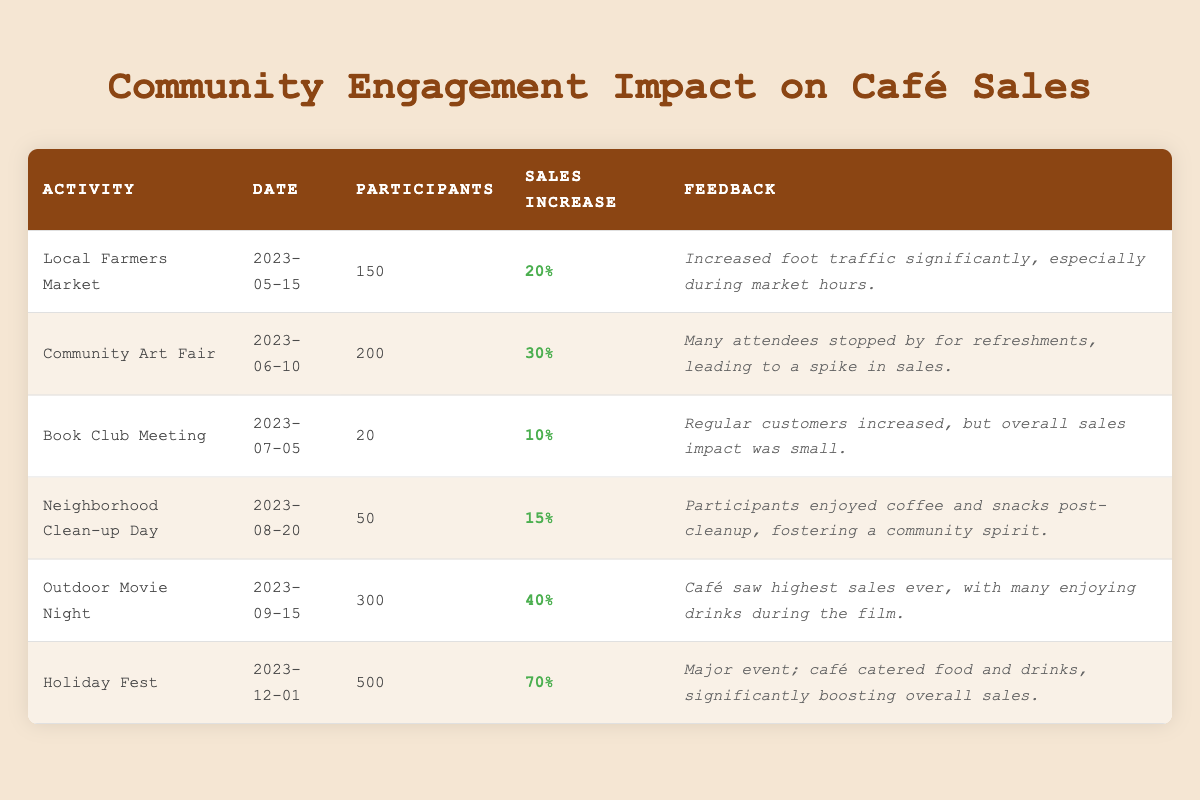What is the café sales increase percentage during the Outdoor Movie Night? The sales increase percentage for the Outdoor Movie Night is directly listed in the table under the "Sales Increase" column. It states 40%.
Answer: 40% How many participants were involved in the Holiday Fest? The number of participants for the Holiday Fest is found under the "Participants" column in the table, which shows a total of 500 attendees.
Answer: 500 Which community engagement activity had the highest sales increase percentage, and what was that percentage? The highest sales increase percentage can be determined by comparing the values in the "Sales Increase" column. Holiday Fest had a 70% increase, which is the highest among all activities.
Answer: Holiday Fest, 70% What is the average sales increase percentage across all activities? To find the average, sum up all the sales increase percentages: (20 + 30 + 10 + 15 + 40 + 70) = 185. Then divide by the number of activities (6): 185 / 6 = 30.83.
Answer: 30.83 Did the Book Club Meeting result in a sales increase of more than 15%? The sales increase percentage for the Book Club Meeting is listed as 10% in the table. Since 10% is less than 15%, the answer is no.
Answer: No How many participants attended the Community Art Fair compared to the Local Farmers Market? The Community Art Fair had 200 participants, whereas the Local Farmers Market had 150 participants. To compare, 200 > 150, meaning the Community Art Fair had more participants.
Answer: Community Art Fair, 200 Is it true that the Neighborhood Clean-up Day increased sales by less than 20%? The sales increase percentage for Neighborhood Clean-up Day is given as 15%. Since 15% is less than 20%, the statement is true.
Answer: Yes What was the feedback regarding the Local Farmers Market? The feedback for the Local Farmers Market can be found in the feedback column of the table, which states that it significantly increased foot traffic, especially during market hours.
Answer: Increased foot traffic significantly, especially during market hours 